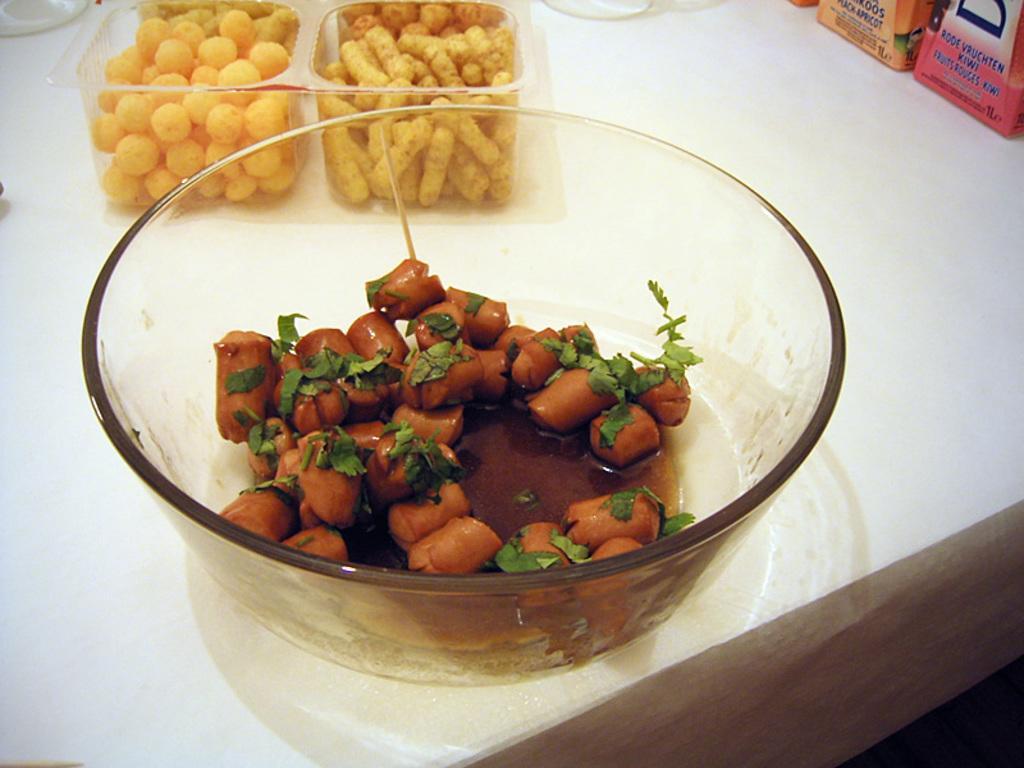Can you describe this image briefly? In this image there are three bowls visible, on which there are food items and bowls kept on table, at the top right there are two packets kept on table. 